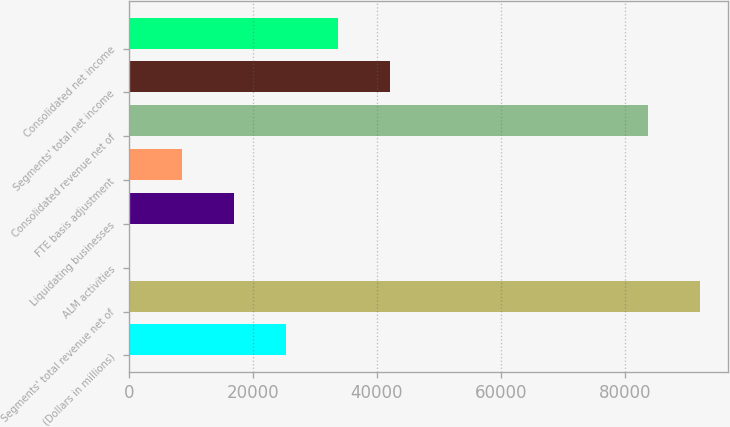<chart> <loc_0><loc_0><loc_500><loc_500><bar_chart><fcel>(Dollars in millions)<fcel>Segments' total revenue net of<fcel>ALM activities<fcel>Liquidating businesses<fcel>FTE basis adjustment<fcel>Consolidated revenue net of<fcel>Segments' total net income<fcel>Consolidated net income<nl><fcel>25384.1<fcel>92062.7<fcel>299<fcel>17022.4<fcel>8660.7<fcel>83701<fcel>42107.5<fcel>33745.8<nl></chart> 